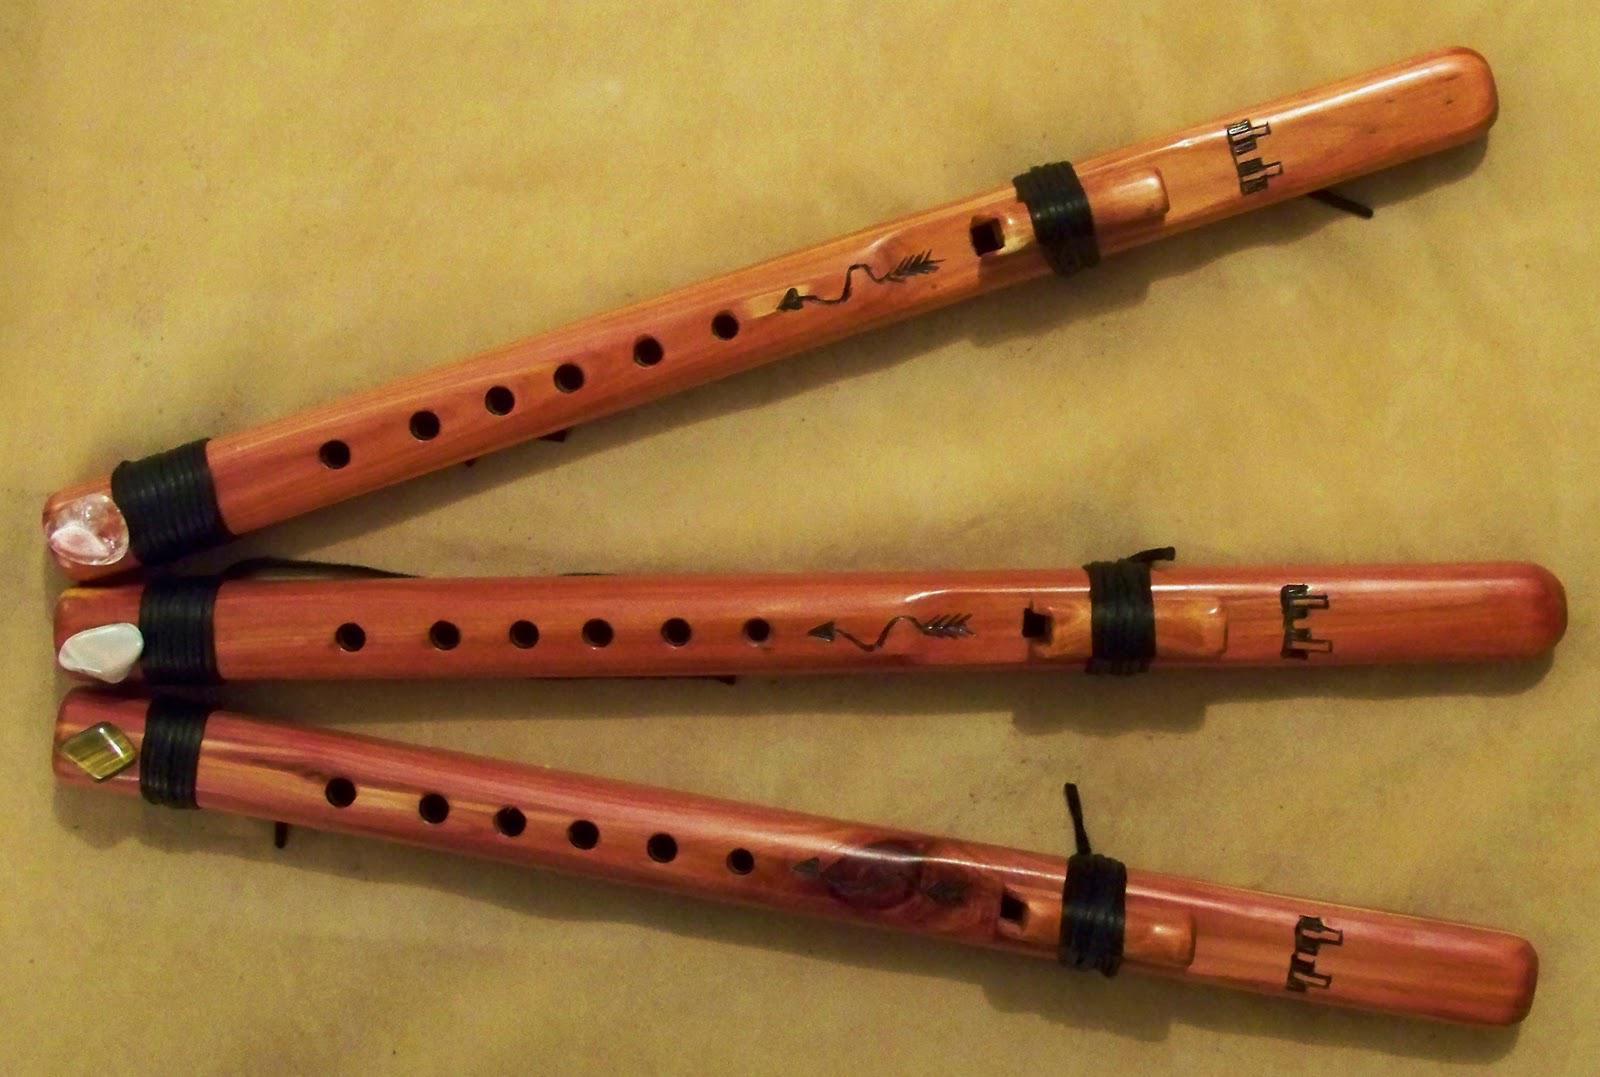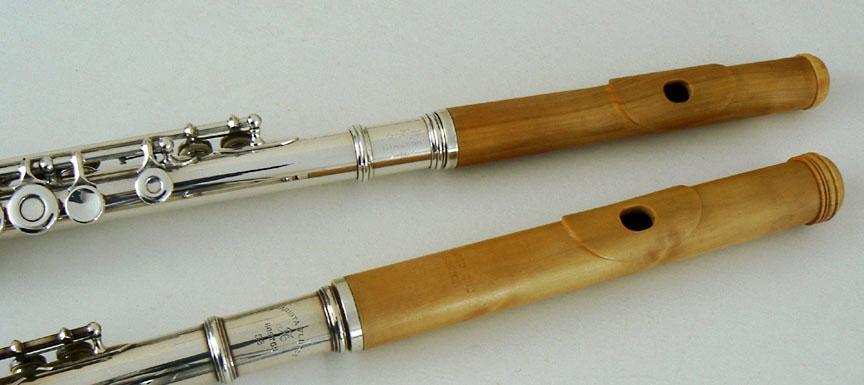The first image is the image on the left, the second image is the image on the right. Considering the images on both sides, is "One image shows at least three flutes with metal keys displayed horizontally and parallel to one another, and the other image shows at least three rows of wooden flute parts displayed the same way." valid? Answer yes or no. No. The first image is the image on the left, the second image is the image on the right. For the images shown, is this caption "In one of the images, the second flute from the bottom is a darker color than the third flute from the bottom." true? Answer yes or no. No. 